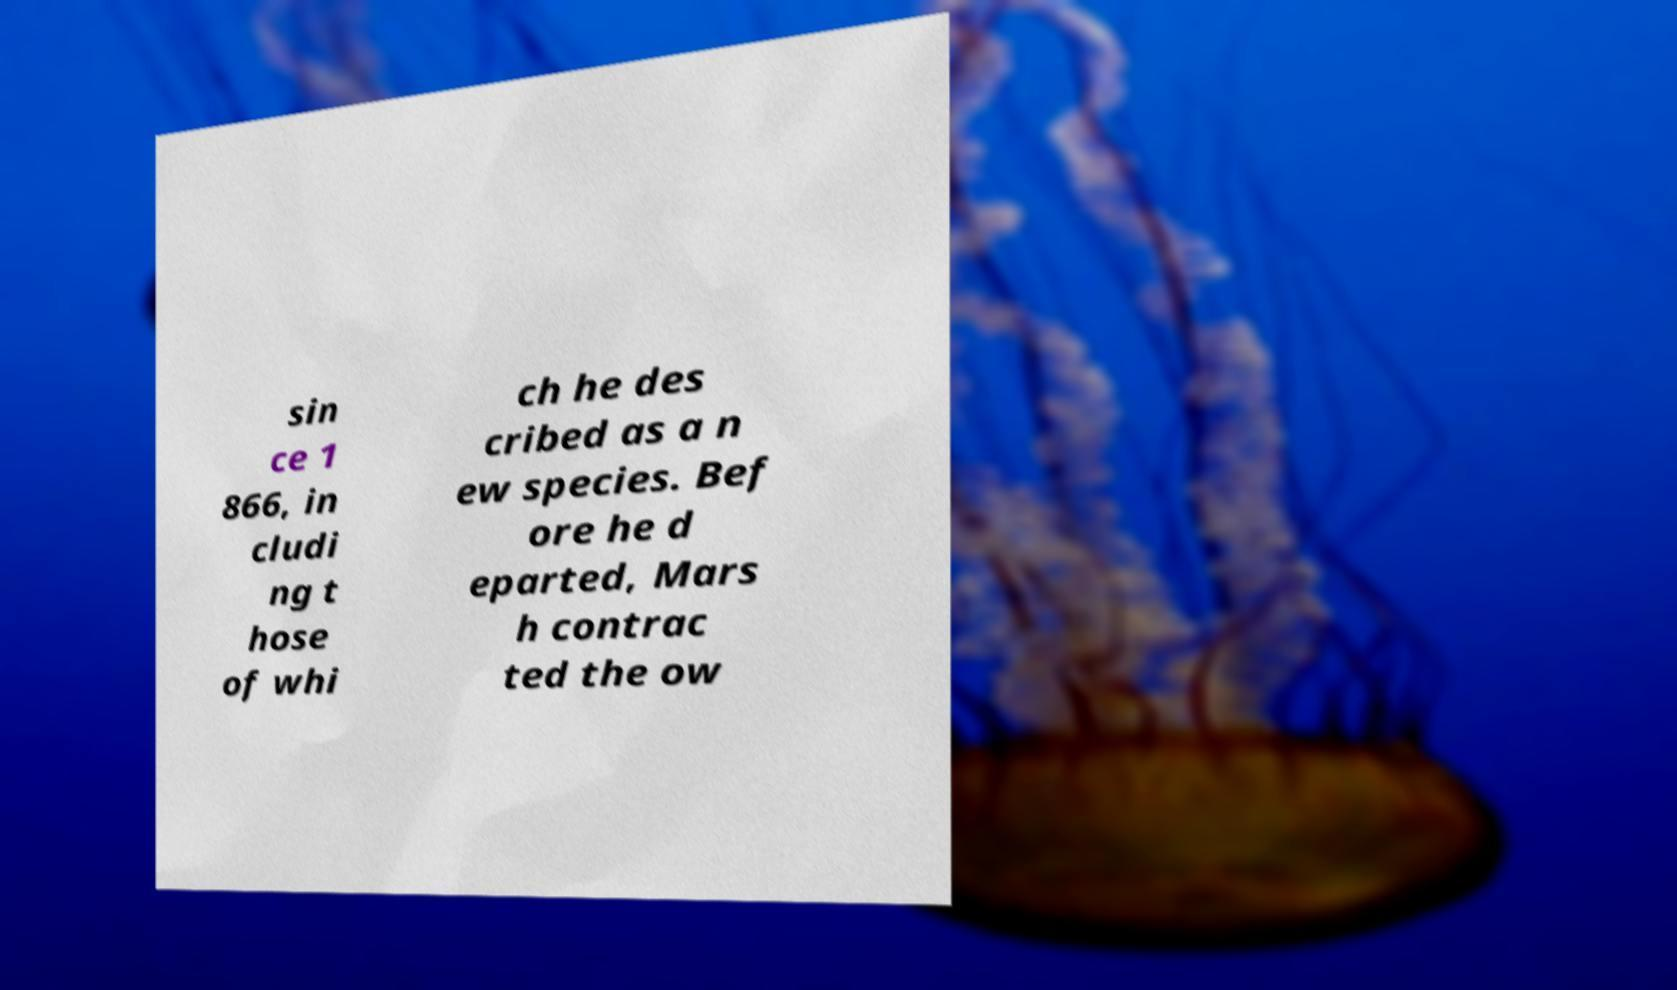What messages or text are displayed in this image? I need them in a readable, typed format. sin ce 1 866, in cludi ng t hose of whi ch he des cribed as a n ew species. Bef ore he d eparted, Mars h contrac ted the ow 